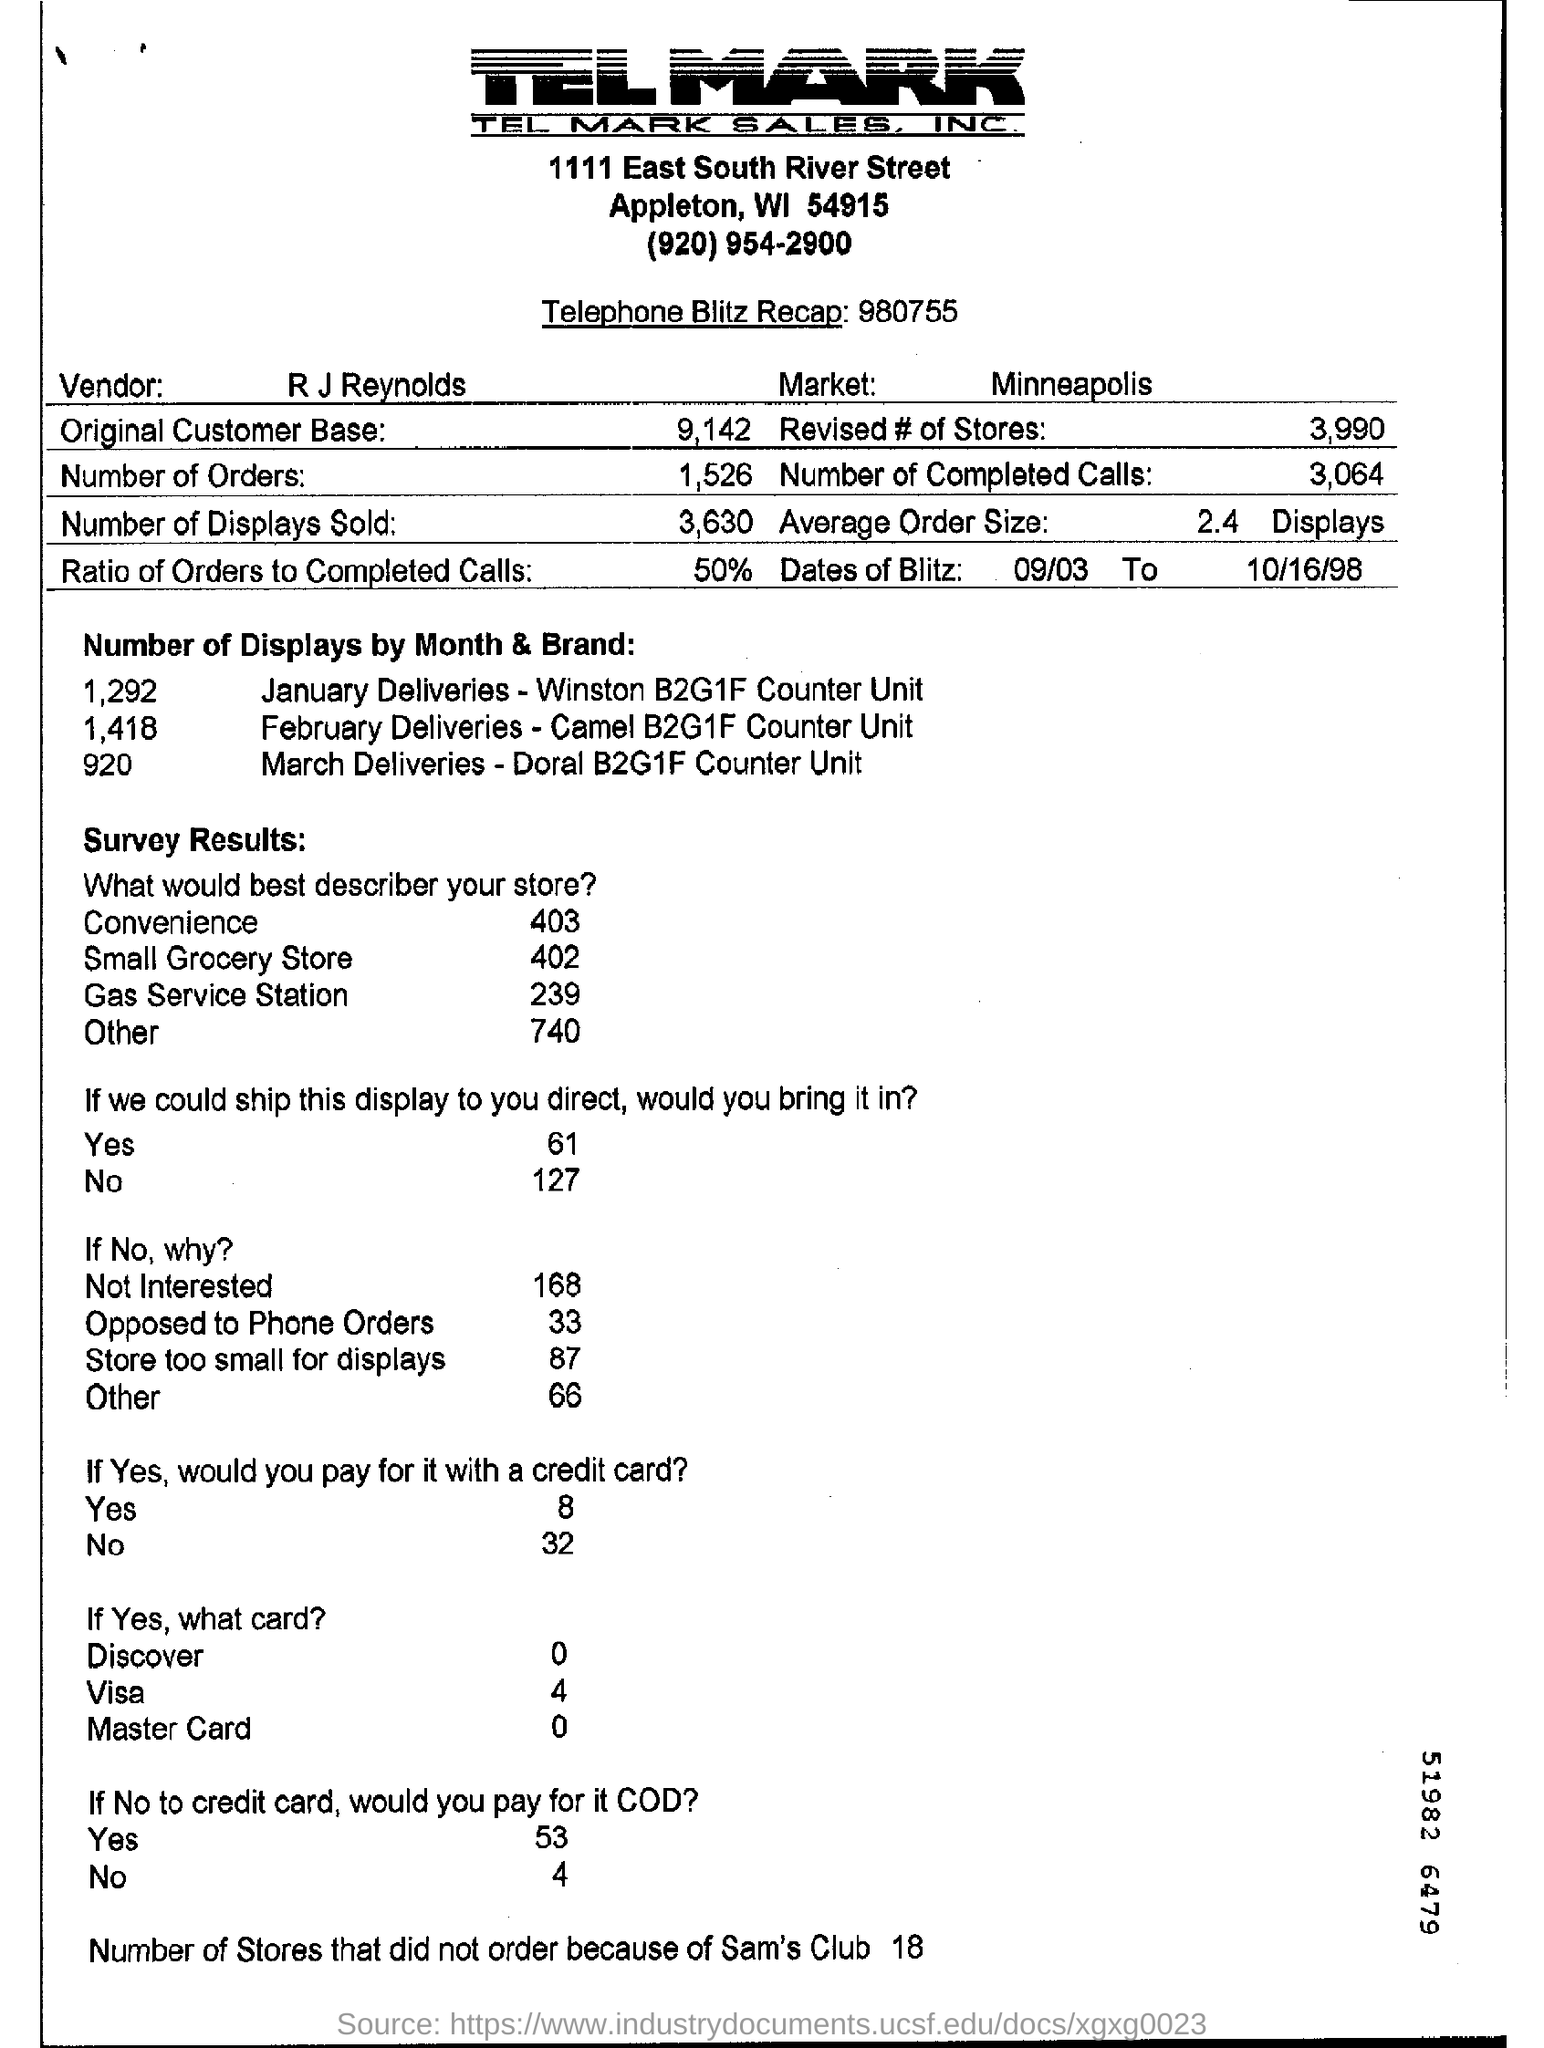Specify some key components in this picture. R J Reynolds is the name of the vendor. There were 1,526 orders in total. 